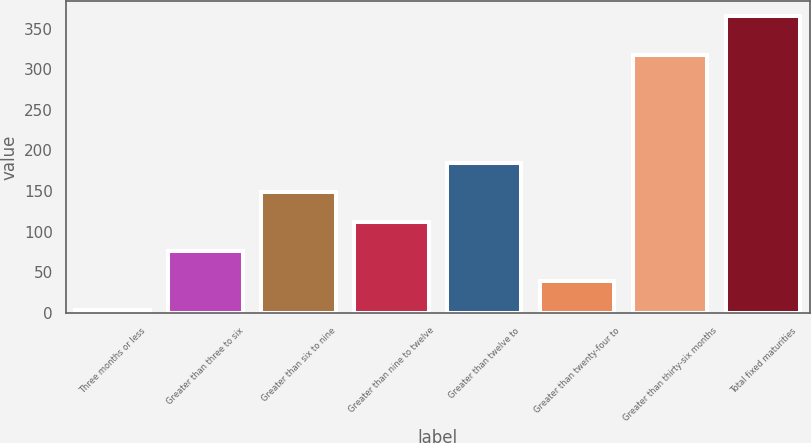<chart> <loc_0><loc_0><loc_500><loc_500><bar_chart><fcel>Three months or less<fcel>Greater than three to six<fcel>Greater than six to nine<fcel>Greater than nine to twelve<fcel>Greater than twelve to<fcel>Greater than twenty-four to<fcel>Greater than thirty-six months<fcel>Total fixed maturities<nl><fcel>3.6<fcel>75.9<fcel>148.2<fcel>112.05<fcel>184.35<fcel>39.75<fcel>317<fcel>365.1<nl></chart> 